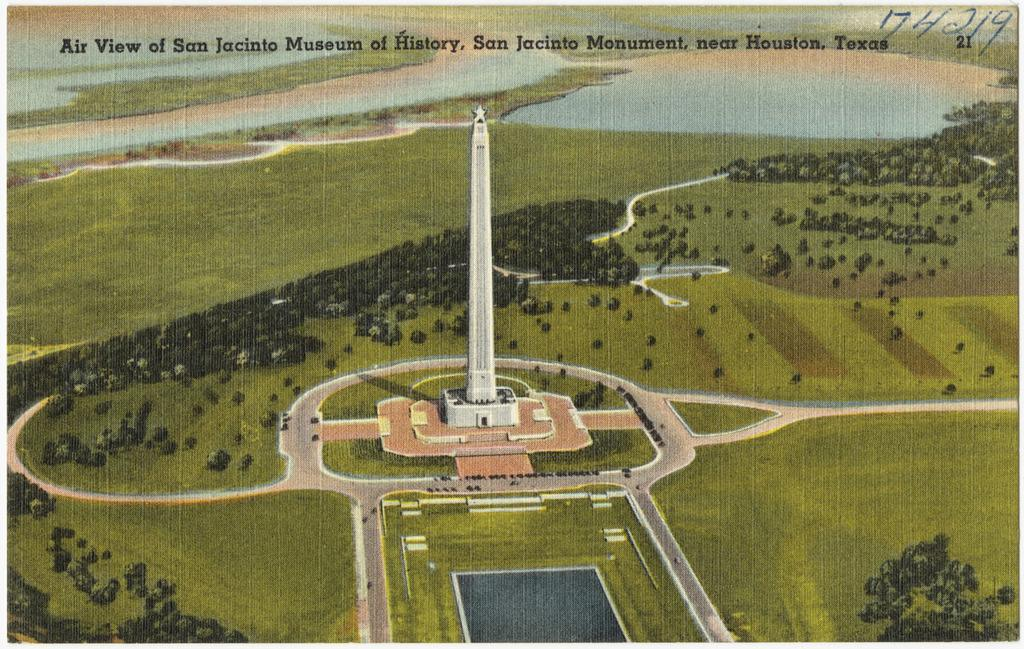What type of image is being described? The image is an animation and graphic. What is the main feature in the center of the image? There is a tower in the center of the image. What type of terrain is depicted in the image? There is grass on the ground in the image. Where is the text located in the image? The text is at the top of the image. Is there a maid in the garden tending to the plants in the image? There is no garden or maid present in the image; it features a tower and grass. Can you see any magical elements in the image? There are no magical elements present in the image. 